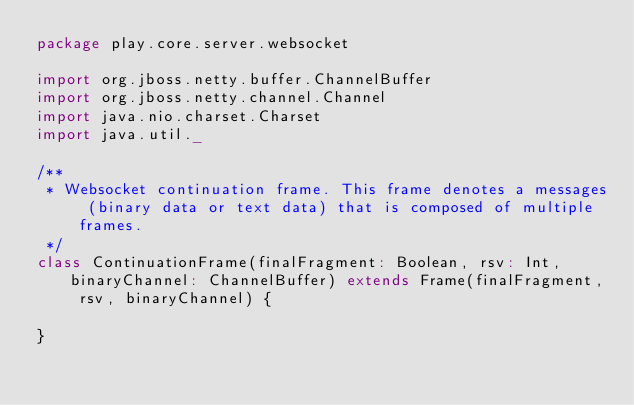Convert code to text. <code><loc_0><loc_0><loc_500><loc_500><_Scala_>package play.core.server.websocket

import org.jboss.netty.buffer.ChannelBuffer
import org.jboss.netty.channel.Channel
import java.nio.charset.Charset
import java.util._

/**
 * Websocket continuation frame. This frame denotes a messages (binary data or text data) that is composed of multiple frames.
 */
class ContinuationFrame(finalFragment: Boolean, rsv: Int, binaryChannel: ChannelBuffer) extends Frame(finalFragment, rsv, binaryChannel) {

}</code> 